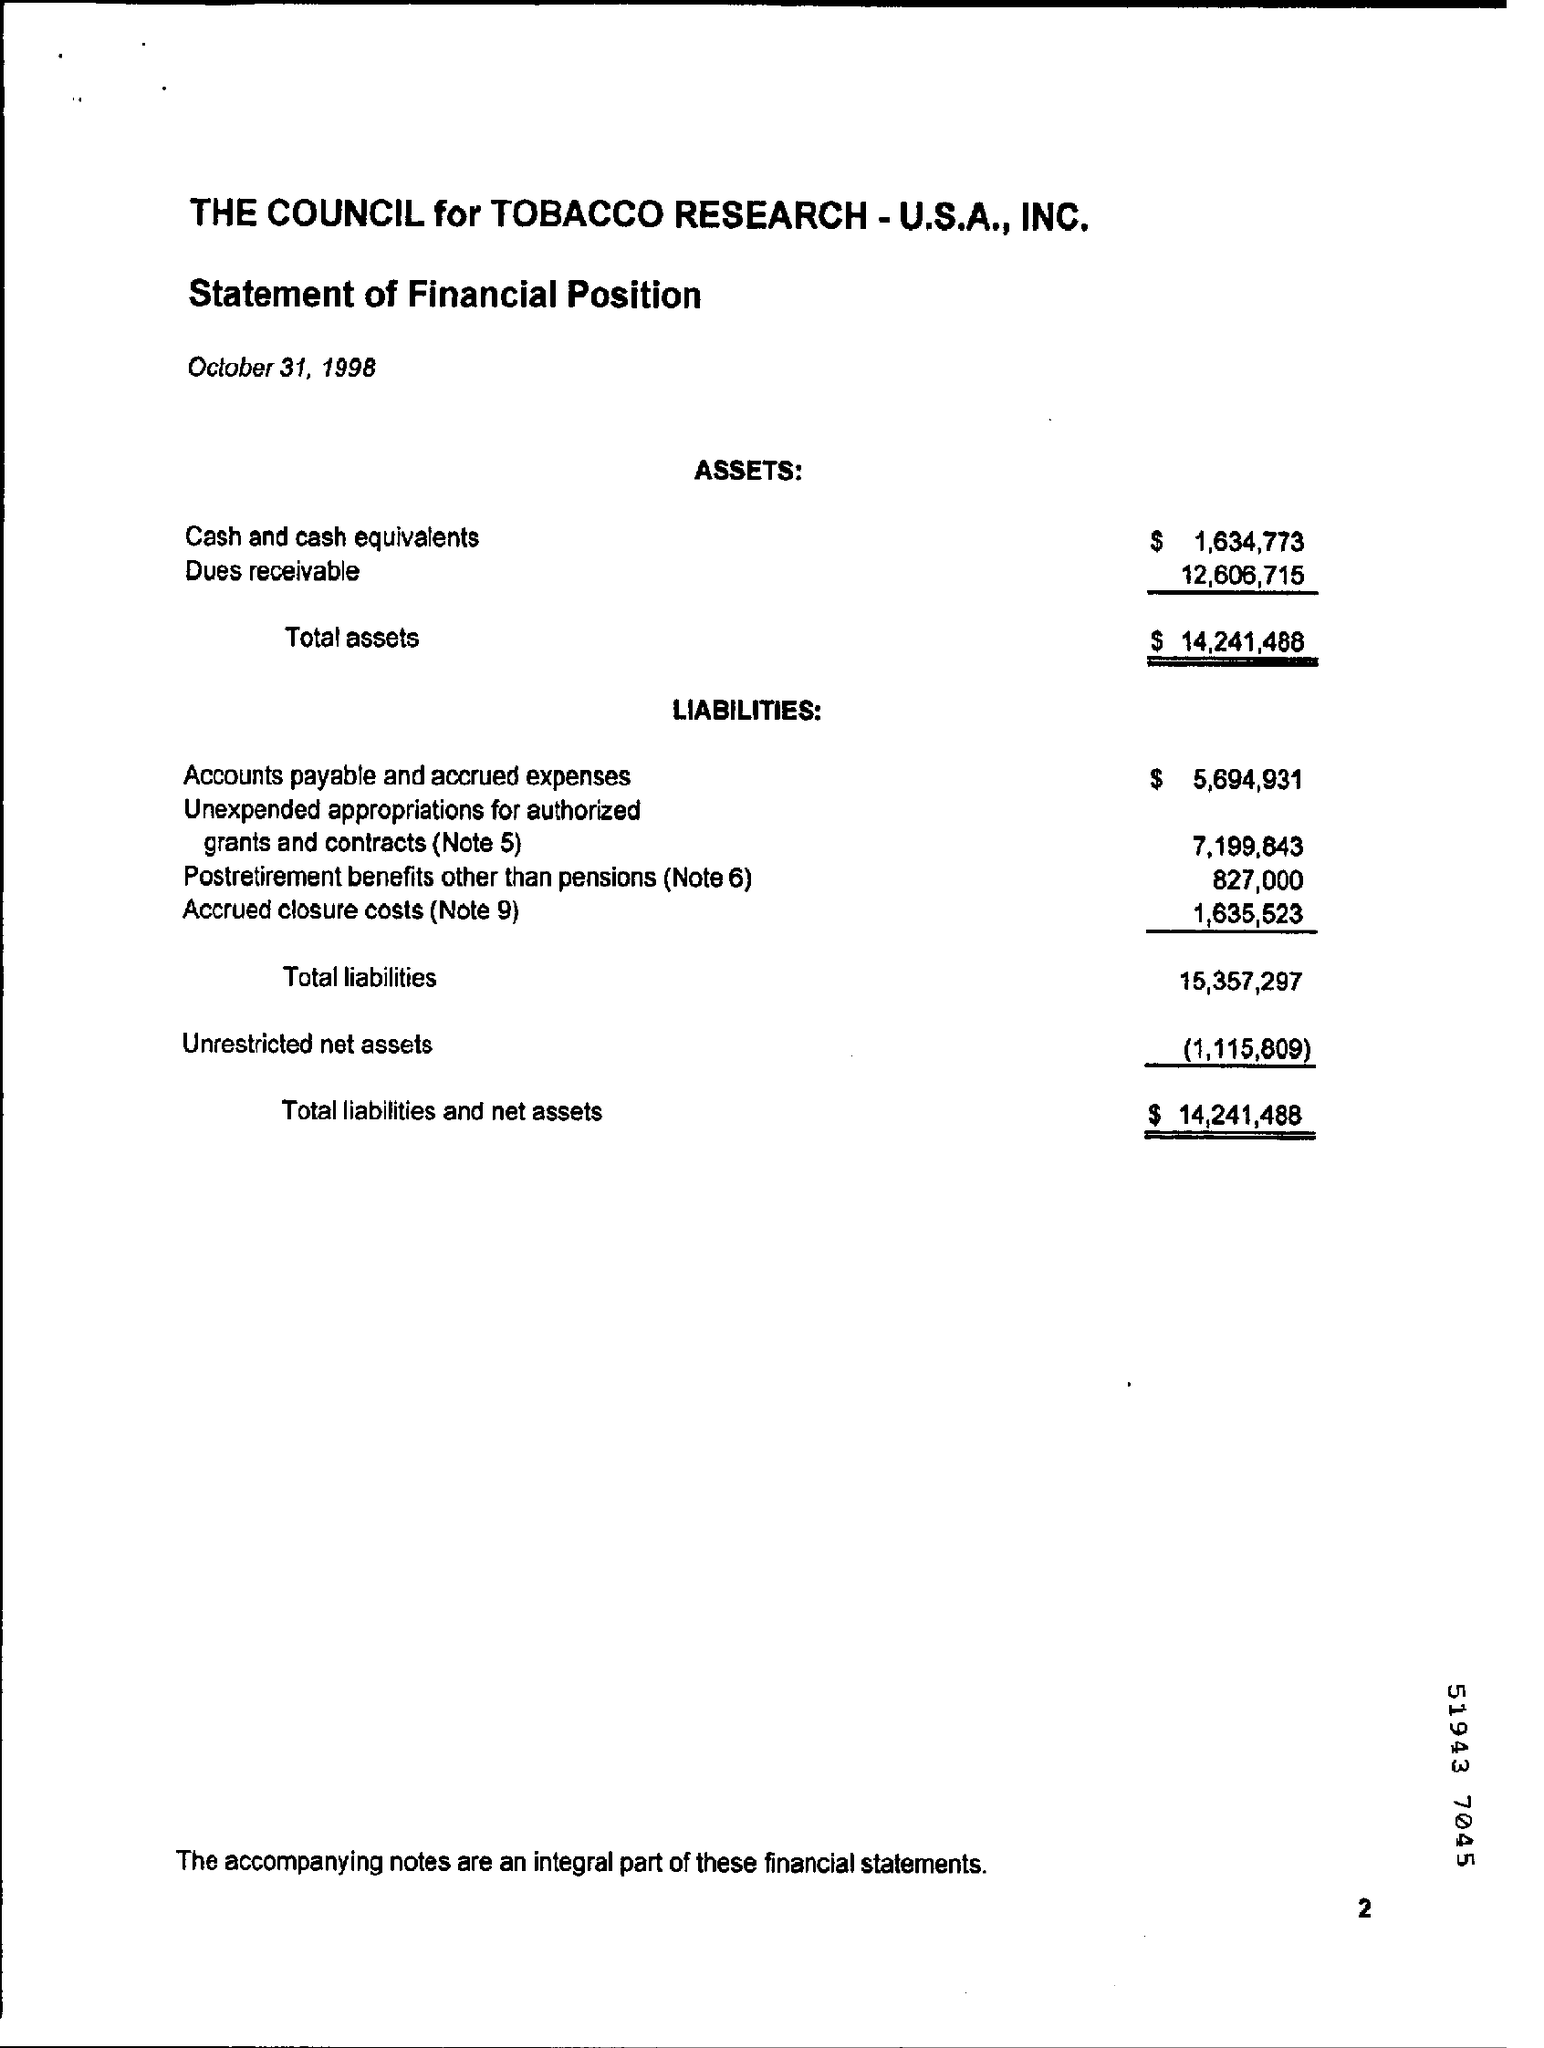Identify some key points in this picture. The document is dated October 31, 1998. The total value of assets is $14,241,488. The value of accounts payable and accrued expenses is $5,694,931. 